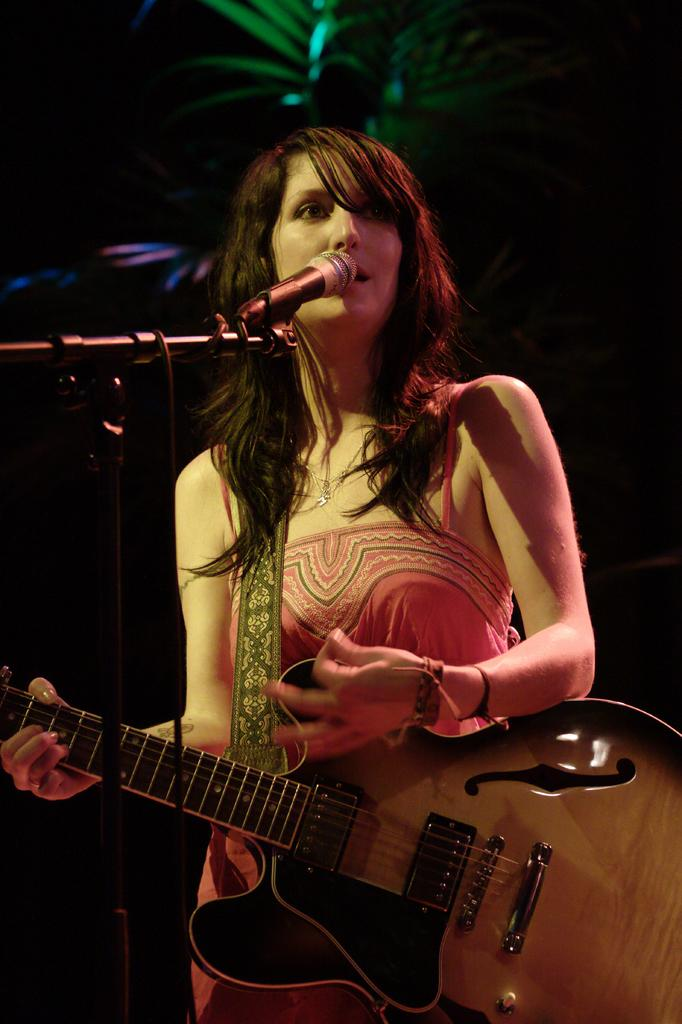Who is the main subject in the image? There is a woman in the image. Where is the woman positioned in the image? The woman is standing in the center. What is the woman holding in the image? The woman is holding a guitar. What is the woman doing with the guitar? The woman is playing the guitar. What is the woman doing with the microphone? The woman is singing on a microphone. Can you see any cobwebs in the image? There is no mention of cobwebs in the image, so we cannot determine if they are present or not. 